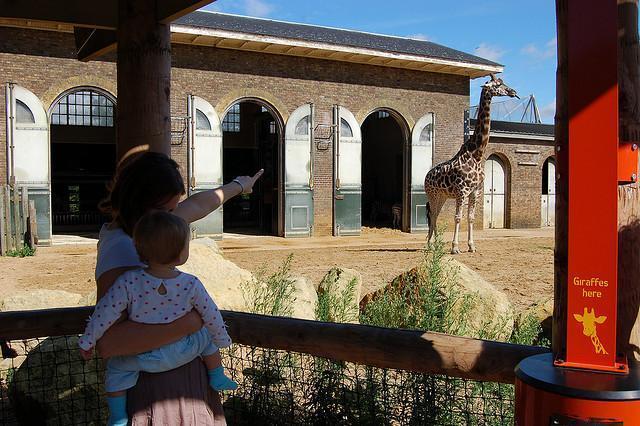How many animals can be seen?
Give a very brief answer. 1. How many people are in the photo?
Give a very brief answer. 2. How many giraffes can you see?
Give a very brief answer. 1. 